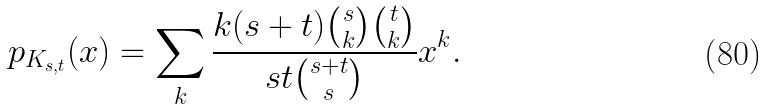<formula> <loc_0><loc_0><loc_500><loc_500>p _ { K _ { s , t } } ( x ) = \sum _ { k } \frac { k ( s + t ) { s \choose k } { t \choose k } } { s t { s + t \choose s } } x ^ { k } .</formula> 